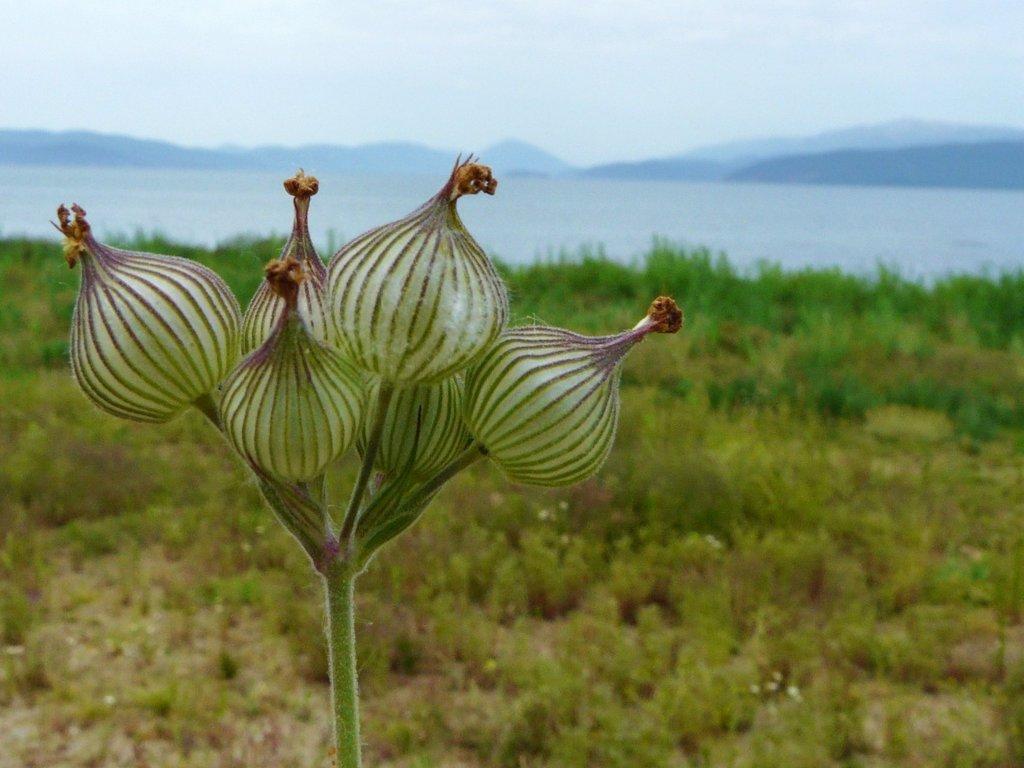In one or two sentences, can you explain what this image depicts? In the picture I can see plants. In the background I can see the water, mountains and the sky. The background of the image is blurred. 